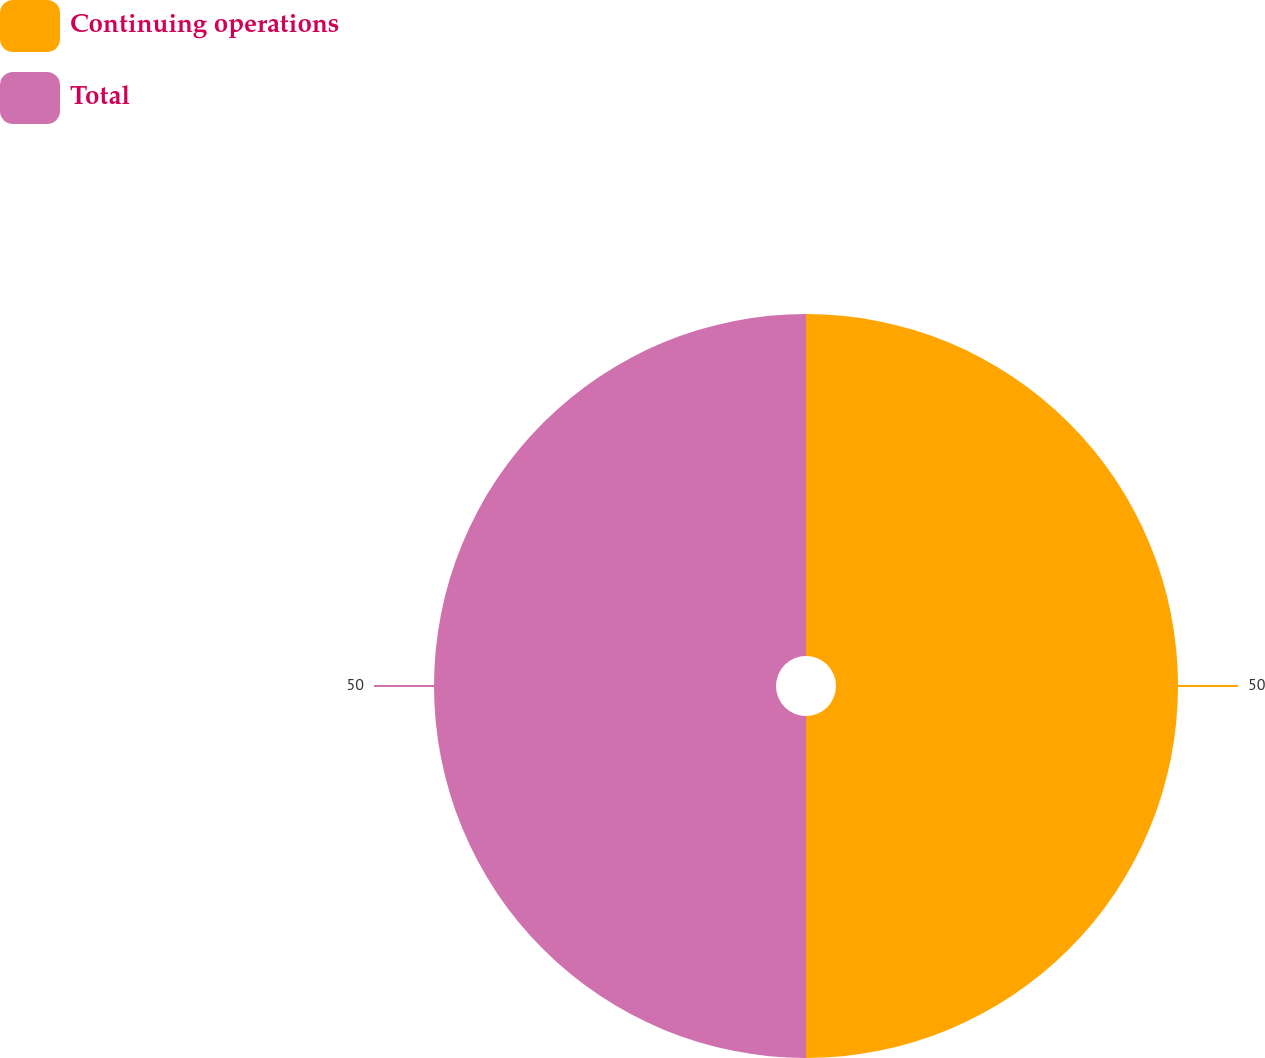Convert chart. <chart><loc_0><loc_0><loc_500><loc_500><pie_chart><fcel>Continuing operations<fcel>Total<nl><fcel>50.0%<fcel>50.0%<nl></chart> 